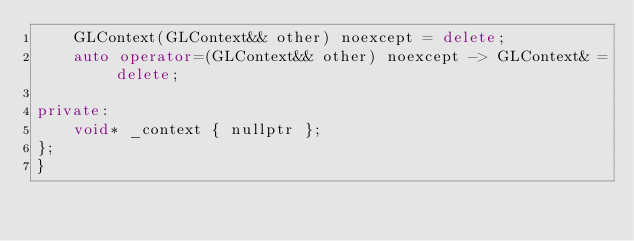<code> <loc_0><loc_0><loc_500><loc_500><_C++_>    GLContext(GLContext&& other) noexcept = delete;
    auto operator=(GLContext&& other) noexcept -> GLContext& = delete;

private:
    void* _context { nullptr };
};
}</code> 